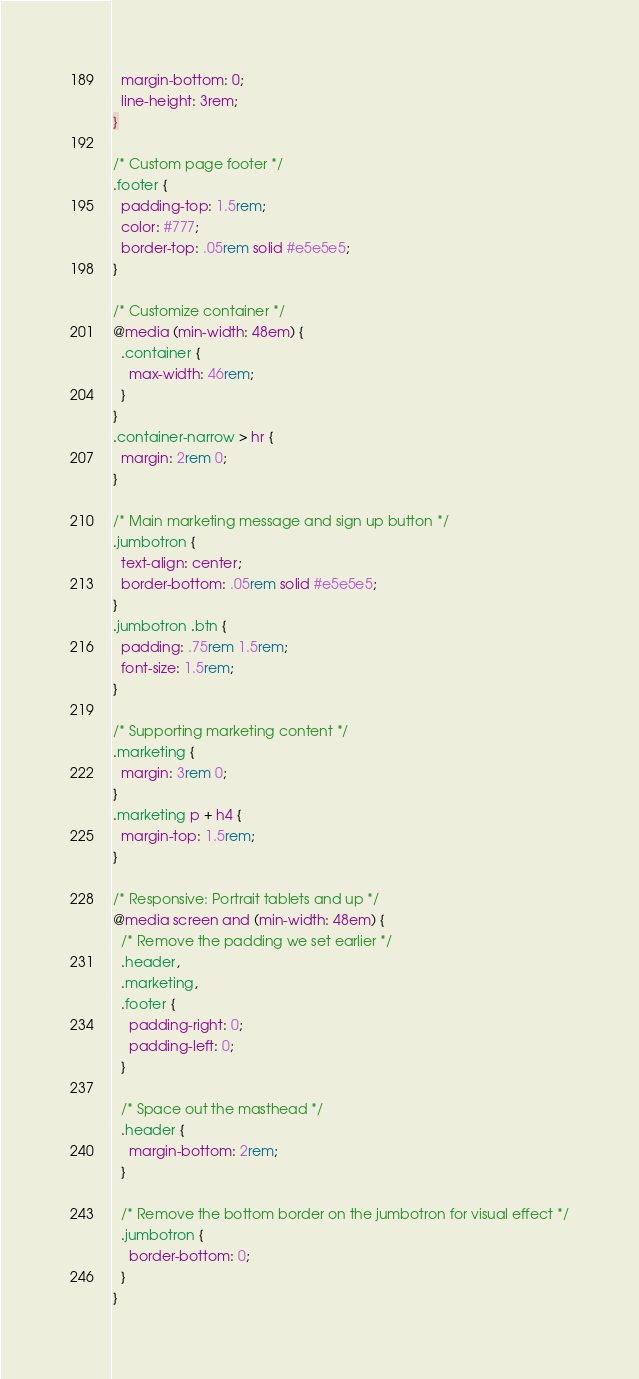Convert code to text. <code><loc_0><loc_0><loc_500><loc_500><_CSS_>  margin-bottom: 0;
  line-height: 3rem;
}

/* Custom page footer */
.footer {
  padding-top: 1.5rem;
  color: #777;
  border-top: .05rem solid #e5e5e5;
}

/* Customize container */
@media (min-width: 48em) {
  .container {
    max-width: 46rem;
  }
}
.container-narrow > hr {
  margin: 2rem 0;
}

/* Main marketing message and sign up button */
.jumbotron {
  text-align: center;
  border-bottom: .05rem solid #e5e5e5;
}
.jumbotron .btn {
  padding: .75rem 1.5rem;
  font-size: 1.5rem;
}

/* Supporting marketing content */
.marketing {
  margin: 3rem 0;
}
.marketing p + h4 {
  margin-top: 1.5rem;
}

/* Responsive: Portrait tablets and up */
@media screen and (min-width: 48em) {
  /* Remove the padding we set earlier */
  .header,
  .marketing,
  .footer {
    padding-right: 0;
    padding-left: 0;
  }

  /* Space out the masthead */
  .header {
    margin-bottom: 2rem;
  }

  /* Remove the bottom border on the jumbotron for visual effect */
  .jumbotron {
    border-bottom: 0;
  }
}</code> 